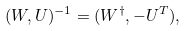Convert formula to latex. <formula><loc_0><loc_0><loc_500><loc_500>( W , U ) ^ { - 1 } = ( W ^ { \dagger } , - U ^ { T } ) ,</formula> 